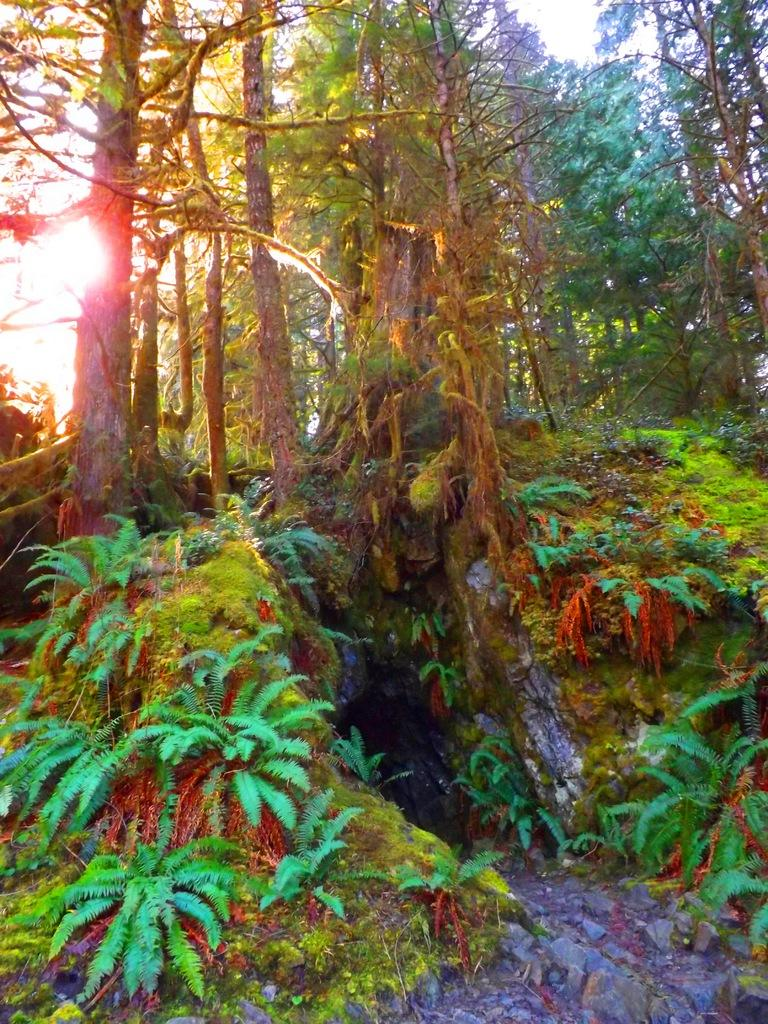What type of design is featured in the image? There are colorful design trees in the image. Where is the sunlight coming from in the image? The sunlight is on the left side of the image. What is visible at the top of the image? The sky is visible at the top of the image. How many parts of the lunch can be seen in the image? There is no lunch present in the image, so it is not possible to determine the number of parts. 